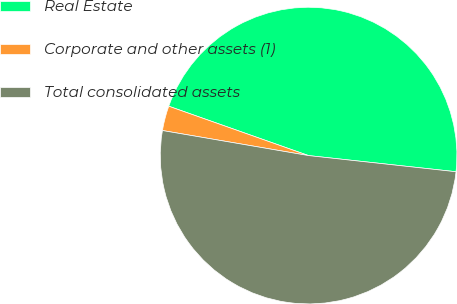Convert chart to OTSL. <chart><loc_0><loc_0><loc_500><loc_500><pie_chart><fcel>Real Estate<fcel>Corporate and other assets (1)<fcel>Total consolidated assets<nl><fcel>46.34%<fcel>2.7%<fcel>50.97%<nl></chart> 